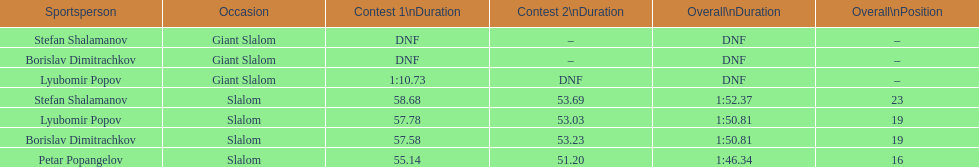Which athlete finished the first race but did not finish the second race? Lyubomir Popov. 